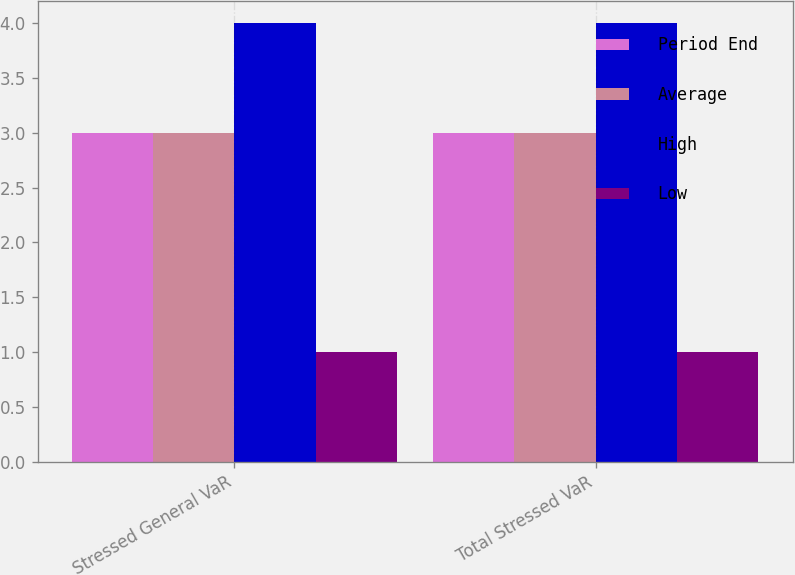Convert chart. <chart><loc_0><loc_0><loc_500><loc_500><stacked_bar_chart><ecel><fcel>Stressed General VaR<fcel>Total Stressed VaR<nl><fcel>Period End<fcel>3<fcel>3<nl><fcel>Average<fcel>3<fcel>3<nl><fcel>High<fcel>4<fcel>4<nl><fcel>Low<fcel>1<fcel>1<nl></chart> 